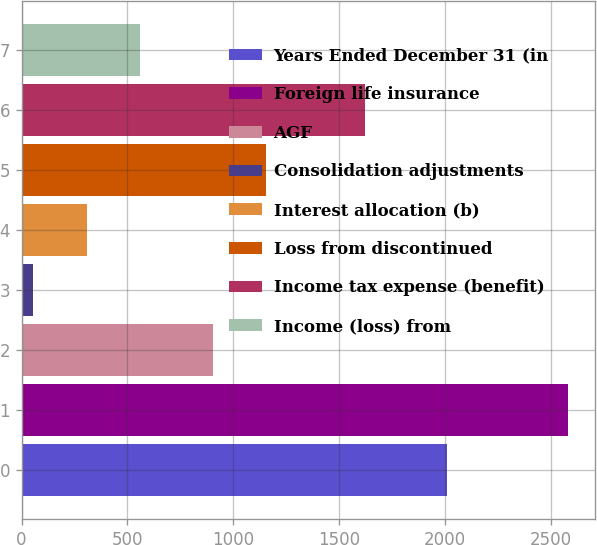Convert chart to OTSL. <chart><loc_0><loc_0><loc_500><loc_500><bar_chart><fcel>Years Ended December 31 (in<fcel>Foreign life insurance<fcel>AGF<fcel>Consolidation adjustments<fcel>Interest allocation (b)<fcel>Loss from discontinued<fcel>Income tax expense (benefit)<fcel>Income (loss) from<nl><fcel>2009<fcel>2581<fcel>904<fcel>54<fcel>306.7<fcel>1156.7<fcel>1621<fcel>559.4<nl></chart> 